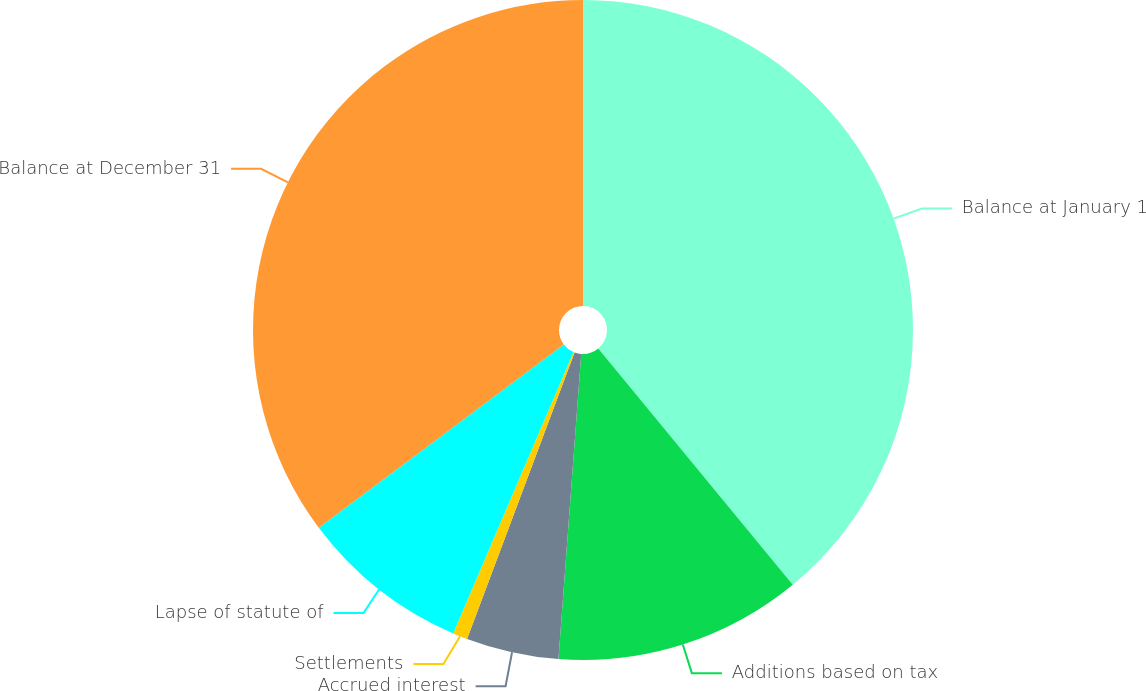<chart> <loc_0><loc_0><loc_500><loc_500><pie_chart><fcel>Balance at January 1<fcel>Additions based on tax<fcel>Accrued interest<fcel>Settlements<fcel>Lapse of statute of<fcel>Balance at December 31<nl><fcel>39.04%<fcel>12.15%<fcel>4.53%<fcel>0.72%<fcel>8.34%<fcel>35.23%<nl></chart> 